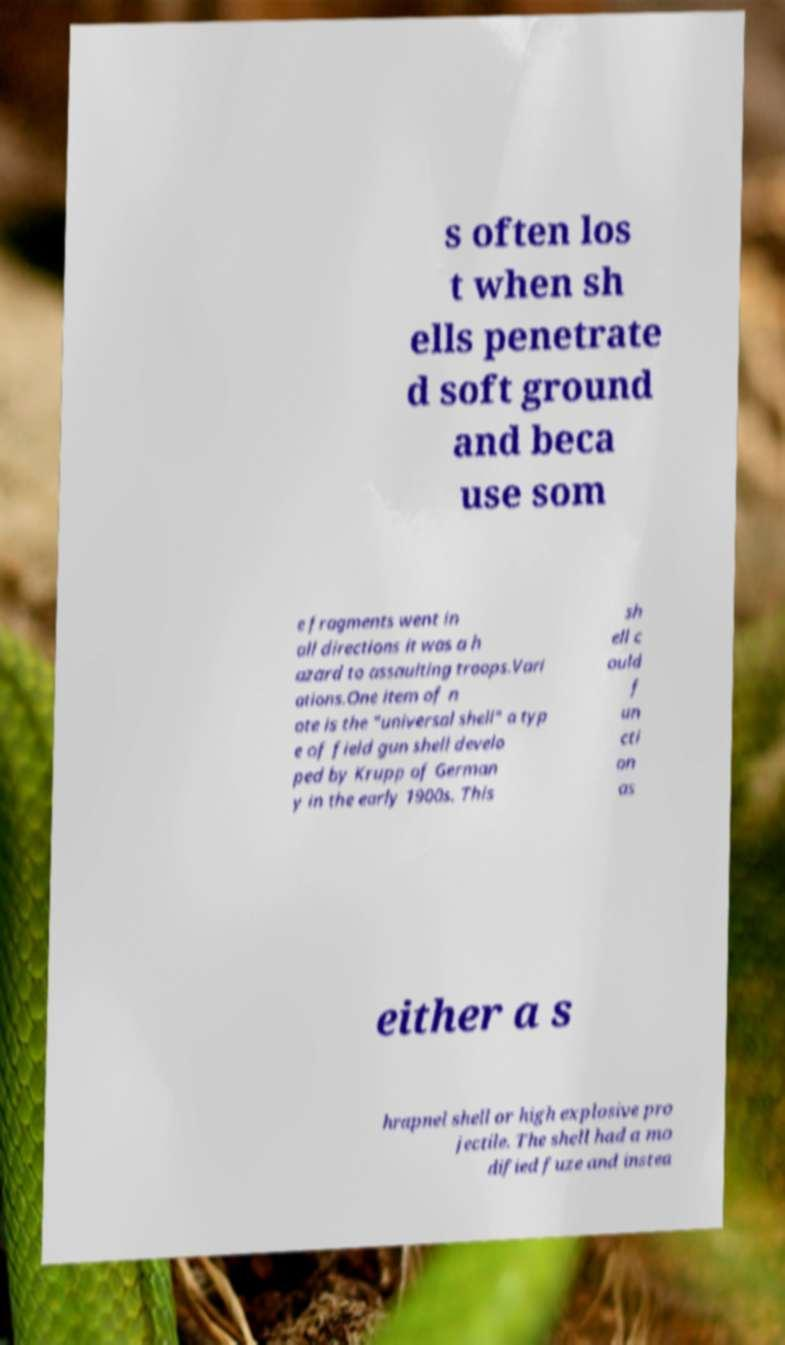Can you accurately transcribe the text from the provided image for me? s often los t when sh ells penetrate d soft ground and beca use som e fragments went in all directions it was a h azard to assaulting troops.Vari ations.One item of n ote is the "universal shell" a typ e of field gun shell develo ped by Krupp of German y in the early 1900s. This sh ell c ould f un cti on as either a s hrapnel shell or high explosive pro jectile. The shell had a mo dified fuze and instea 